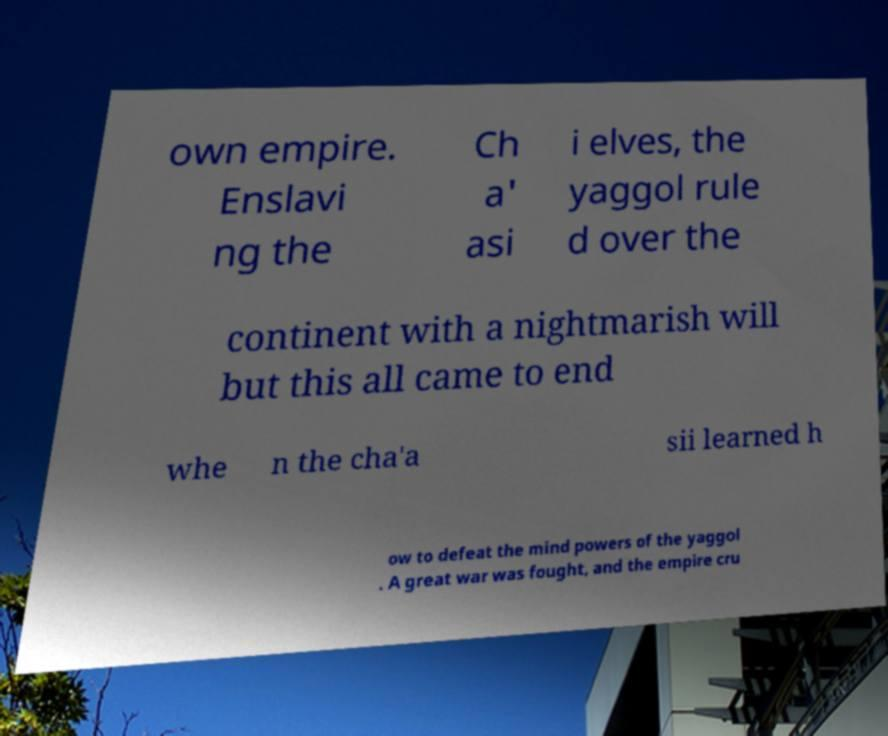Please read and relay the text visible in this image. What does it say? own empire. Enslavi ng the Ch a' asi i elves, the yaggol rule d over the continent with a nightmarish will but this all came to end whe n the cha'a sii learned h ow to defeat the mind powers of the yaggol . A great war was fought, and the empire cru 